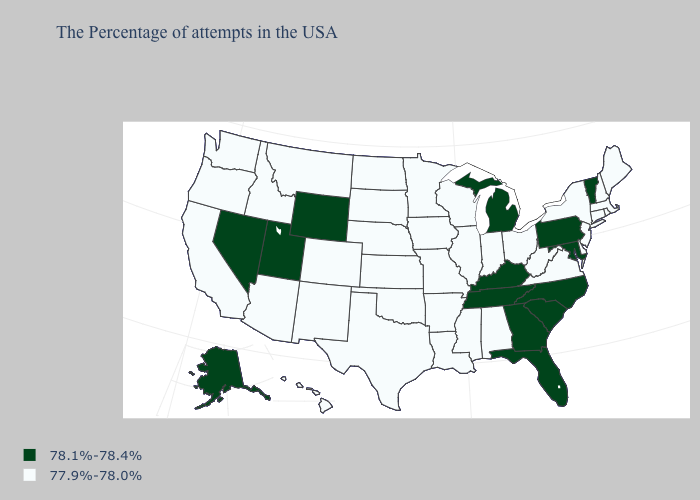Does the map have missing data?
Short answer required. No. Name the states that have a value in the range 77.9%-78.0%?
Concise answer only. Maine, Massachusetts, Rhode Island, New Hampshire, Connecticut, New York, New Jersey, Delaware, Virginia, West Virginia, Ohio, Indiana, Alabama, Wisconsin, Illinois, Mississippi, Louisiana, Missouri, Arkansas, Minnesota, Iowa, Kansas, Nebraska, Oklahoma, Texas, South Dakota, North Dakota, Colorado, New Mexico, Montana, Arizona, Idaho, California, Washington, Oregon, Hawaii. Name the states that have a value in the range 78.1%-78.4%?
Write a very short answer. Vermont, Maryland, Pennsylvania, North Carolina, South Carolina, Florida, Georgia, Michigan, Kentucky, Tennessee, Wyoming, Utah, Nevada, Alaska. Name the states that have a value in the range 77.9%-78.0%?
Give a very brief answer. Maine, Massachusetts, Rhode Island, New Hampshire, Connecticut, New York, New Jersey, Delaware, Virginia, West Virginia, Ohio, Indiana, Alabama, Wisconsin, Illinois, Mississippi, Louisiana, Missouri, Arkansas, Minnesota, Iowa, Kansas, Nebraska, Oklahoma, Texas, South Dakota, North Dakota, Colorado, New Mexico, Montana, Arizona, Idaho, California, Washington, Oregon, Hawaii. What is the lowest value in the USA?
Short answer required. 77.9%-78.0%. Name the states that have a value in the range 78.1%-78.4%?
Keep it brief. Vermont, Maryland, Pennsylvania, North Carolina, South Carolina, Florida, Georgia, Michigan, Kentucky, Tennessee, Wyoming, Utah, Nevada, Alaska. What is the highest value in the USA?
Answer briefly. 78.1%-78.4%. Which states have the highest value in the USA?
Concise answer only. Vermont, Maryland, Pennsylvania, North Carolina, South Carolina, Florida, Georgia, Michigan, Kentucky, Tennessee, Wyoming, Utah, Nevada, Alaska. Which states hav the highest value in the Northeast?
Write a very short answer. Vermont, Pennsylvania. Which states have the highest value in the USA?
Give a very brief answer. Vermont, Maryland, Pennsylvania, North Carolina, South Carolina, Florida, Georgia, Michigan, Kentucky, Tennessee, Wyoming, Utah, Nevada, Alaska. Does Minnesota have a lower value than Tennessee?
Concise answer only. Yes. What is the highest value in states that border Montana?
Answer briefly. 78.1%-78.4%. What is the lowest value in the Northeast?
Answer briefly. 77.9%-78.0%. Among the states that border Arkansas , which have the highest value?
Be succinct. Tennessee. Among the states that border Massachusetts , does New York have the lowest value?
Keep it brief. Yes. 